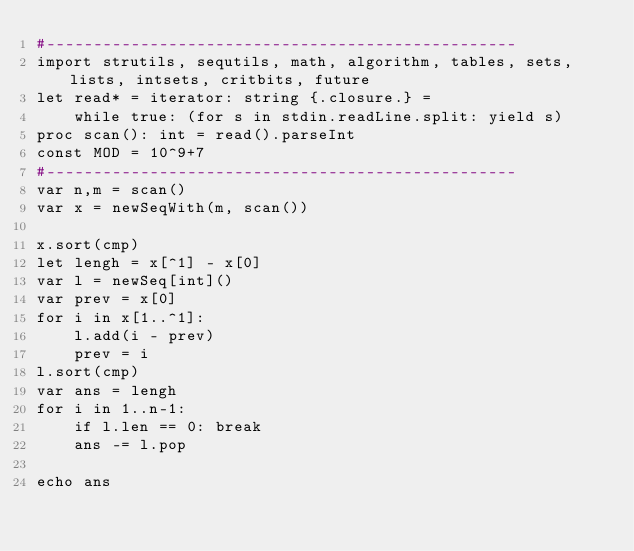<code> <loc_0><loc_0><loc_500><loc_500><_Nim_>#--------------------------------------------------
import strutils, sequtils, math, algorithm, tables, sets, lists, intsets, critbits, future
let read* = iterator: string {.closure.} =
    while true: (for s in stdin.readLine.split: yield s)
proc scan(): int = read().parseInt
const MOD = 10^9+7
#--------------------------------------------------
var n,m = scan()
var x = newSeqWith(m, scan())

x.sort(cmp)
let lengh = x[^1] - x[0]
var l = newSeq[int]()
var prev = x[0]
for i in x[1..^1]:
    l.add(i - prev)
    prev = i
l.sort(cmp)
var ans = lengh
for i in 1..n-1:
    if l.len == 0: break
    ans -= l.pop

echo ans
</code> 